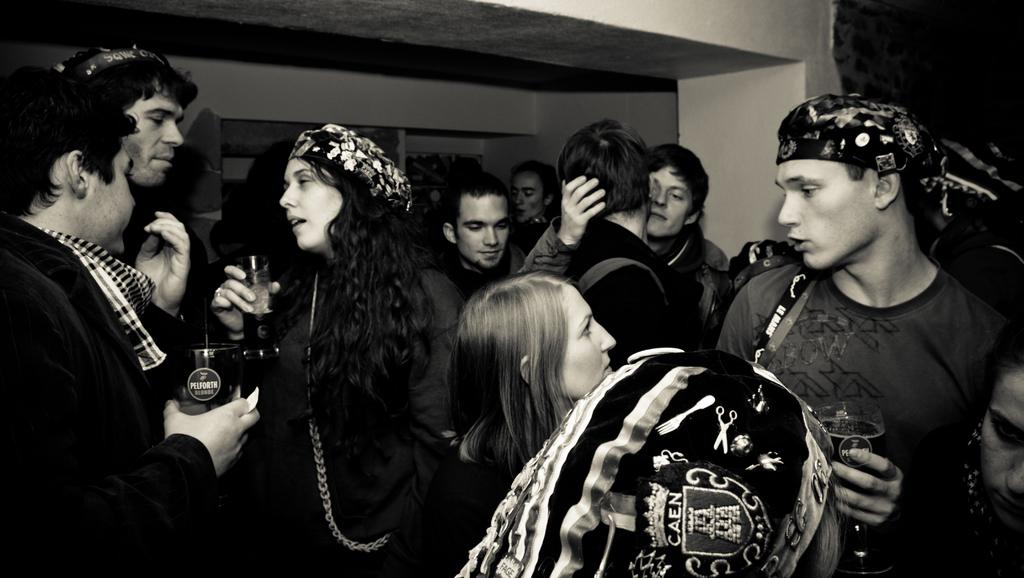How many people are in the image? There are many persons in the image. What are the man and woman on the left side of the image doing? They are holding glasses. What can be seen in the background of the image? There is a wall in the background of the image. What is the color scheme of the image? The image is in black and white. What is the weight of the car in the image? There is no car present in the image, so it is not possible to determine its weight. 